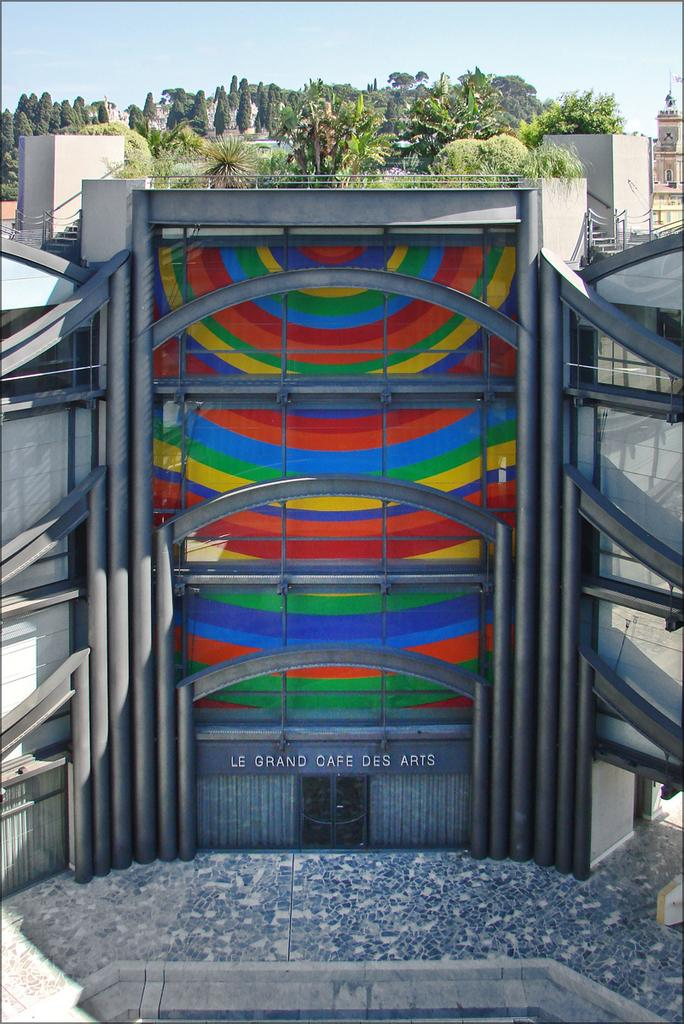What type of structure is present in the image? There is a building in the image. What other elements can be seen in the image? There are trees and the sky visible in the image. What is written on the building? There is something written on the building. How are the walls of the building designed? The building has designed glass walls. What type of tooth can be seen in the image? There is no tooth present in the image. What flavor of cake is being served in the image? There is no cake present in the image. 